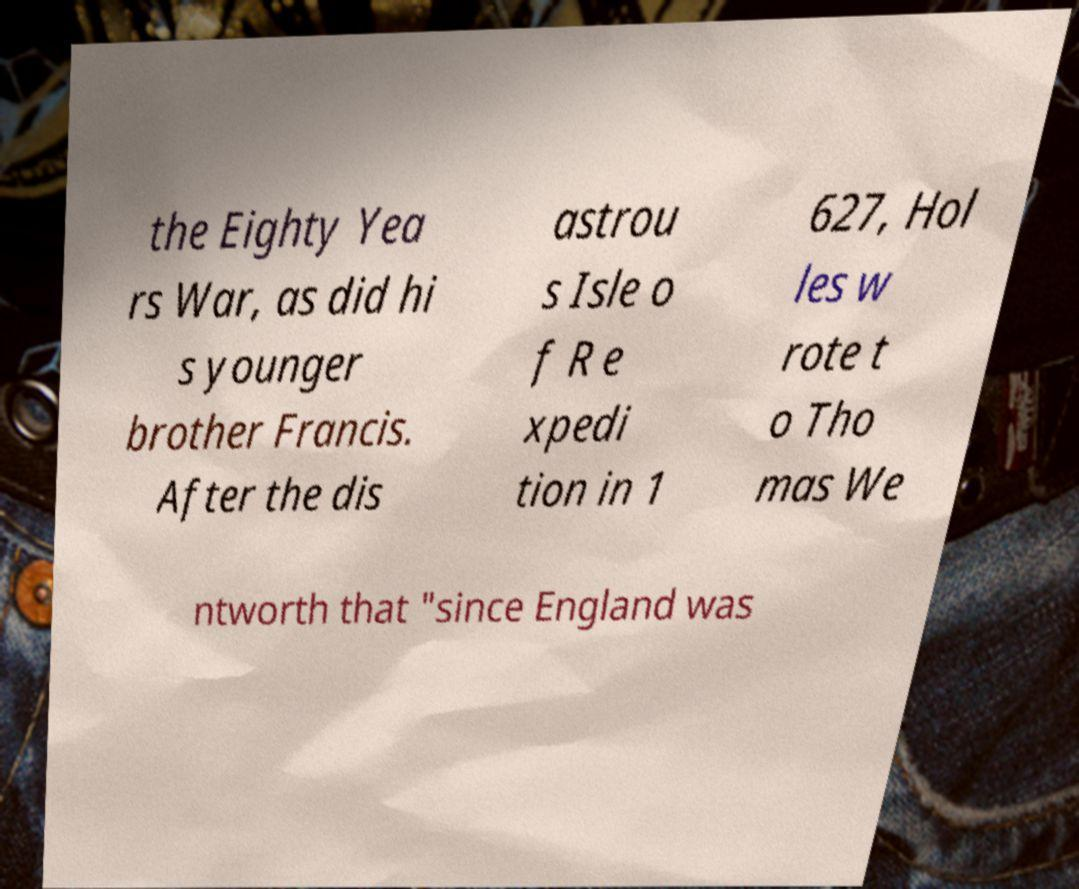Please read and relay the text visible in this image. What does it say? the Eighty Yea rs War, as did hi s younger brother Francis. After the dis astrou s Isle o f R e xpedi tion in 1 627, Hol les w rote t o Tho mas We ntworth that "since England was 